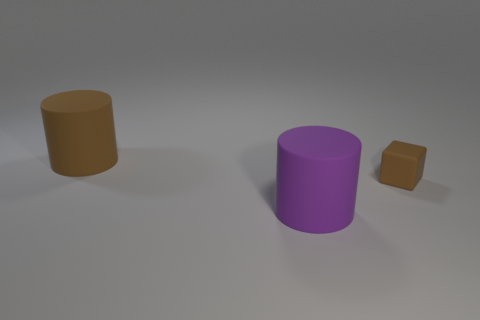There is a large rubber cylinder to the right of the big brown cylinder; what is its color?
Give a very brief answer. Purple. There is a large thing in front of the big matte thing behind the tiny cube; what shape is it?
Give a very brief answer. Cylinder. What number of cylinders are either large things or large purple objects?
Your response must be concise. 2. The object that is behind the big purple matte cylinder and left of the tiny object is made of what material?
Keep it short and to the point. Rubber. What number of large purple cylinders are on the left side of the brown matte block?
Provide a short and direct response. 1. Do the big cylinder that is in front of the tiny object and the brown thing left of the large purple cylinder have the same material?
Your answer should be compact. Yes. How many things are either rubber cylinders that are behind the tiny brown matte thing or tiny cyan shiny blocks?
Make the answer very short. 1. Are there fewer big purple rubber things to the right of the small thing than large purple objects on the left side of the big brown cylinder?
Provide a succinct answer. No. What number of other things are the same size as the purple rubber cylinder?
Your answer should be compact. 1. How many things are either rubber objects to the right of the large purple rubber cylinder or objects left of the tiny brown object?
Offer a terse response. 3. 